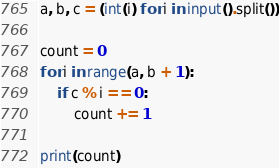<code> <loc_0><loc_0><loc_500><loc_500><_Python_>a, b, c = (int(i) for i in input().split())

count = 0
for i in range(a, b + 1):
    if c % i == 0:
        count += 1

print(count)

</code> 